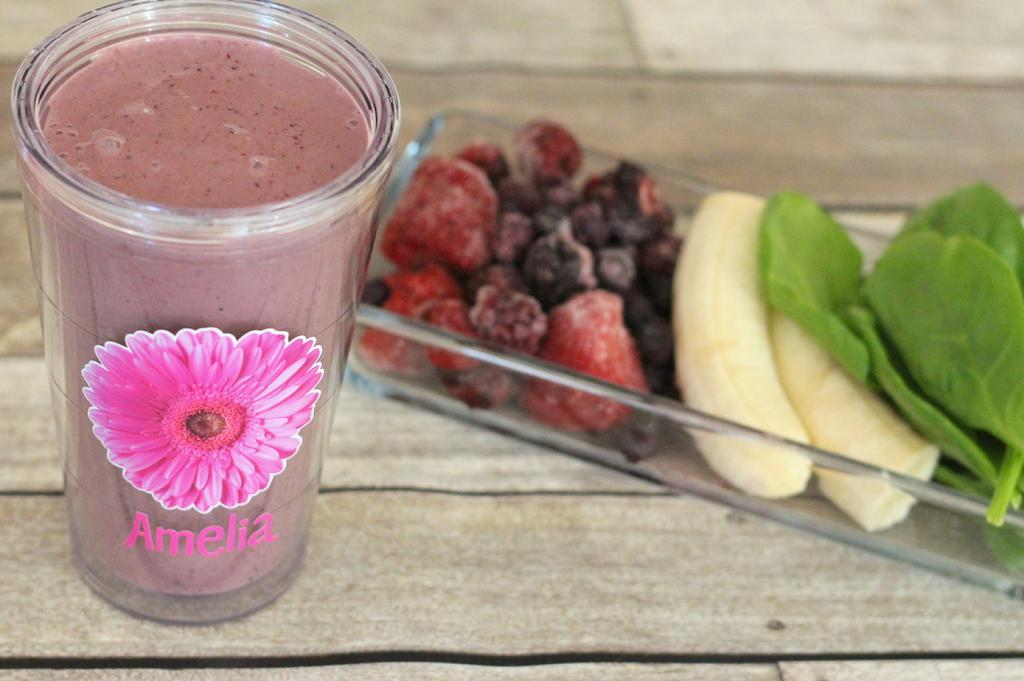What is the main object in the image? There is a wooden plank in the image. What is placed on the wooden plank? There is a glass of juice on the wooden plank. What else can be seen on the wooden plank or nearby? There is a tray with banana slices, vegetable leaves, and fruits in the image. What color is the throne in the image? There is no throne present in the image. How many times does the fruit get painted in the image? There is no painting or painting process depicted in the image. 